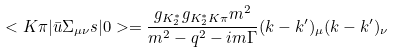Convert formula to latex. <formula><loc_0><loc_0><loc_500><loc_500>< K \pi | \bar { u } \Sigma _ { \mu \nu } s | 0 > = \frac { g _ { K _ { 2 } ^ { * } } g _ { K _ { 2 } ^ { * } K \pi } m ^ { 2 } } { m ^ { 2 } - q ^ { 2 } - i m \Gamma } ( k - k ^ { \prime } ) _ { \mu } ( k - k ^ { \prime } ) _ { \nu }</formula> 